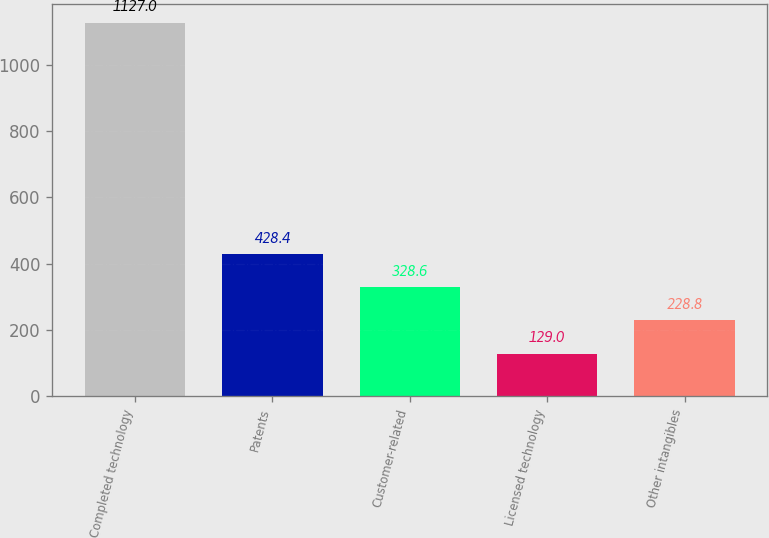<chart> <loc_0><loc_0><loc_500><loc_500><bar_chart><fcel>Completed technology<fcel>Patents<fcel>Customer-related<fcel>Licensed technology<fcel>Other intangibles<nl><fcel>1127<fcel>428.4<fcel>328.6<fcel>129<fcel>228.8<nl></chart> 